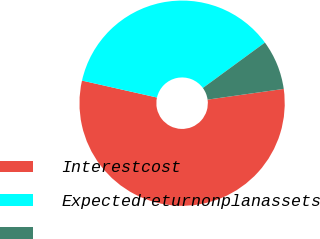Convert chart to OTSL. <chart><loc_0><loc_0><loc_500><loc_500><pie_chart><fcel>Interestcost<fcel>Expectedreturnonplanassets<fcel>Unnamed: 2<nl><fcel>55.76%<fcel>36.41%<fcel>7.83%<nl></chart> 